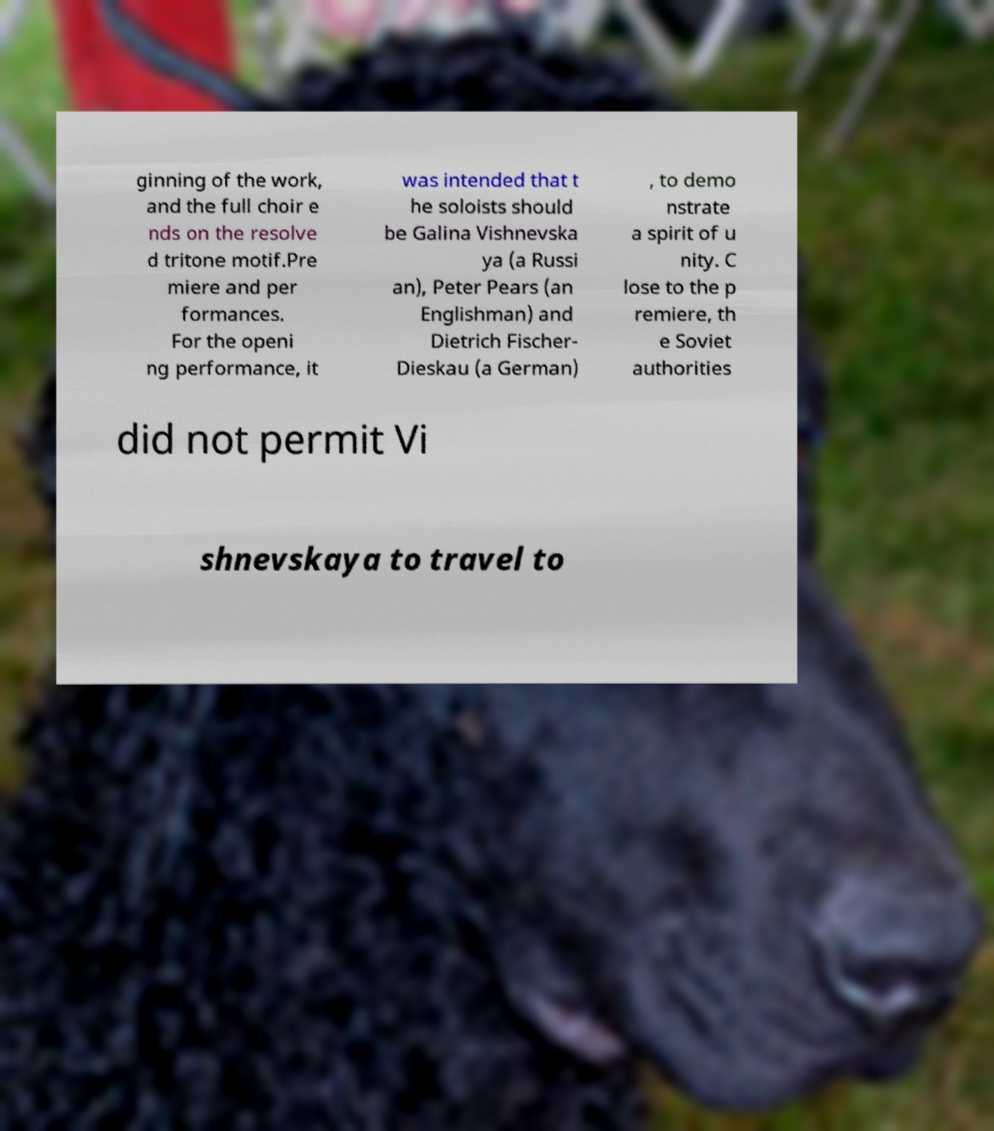Could you assist in decoding the text presented in this image and type it out clearly? ginning of the work, and the full choir e nds on the resolve d tritone motif.Pre miere and per formances. For the openi ng performance, it was intended that t he soloists should be Galina Vishnevska ya (a Russi an), Peter Pears (an Englishman) and Dietrich Fischer- Dieskau (a German) , to demo nstrate a spirit of u nity. C lose to the p remiere, th e Soviet authorities did not permit Vi shnevskaya to travel to 